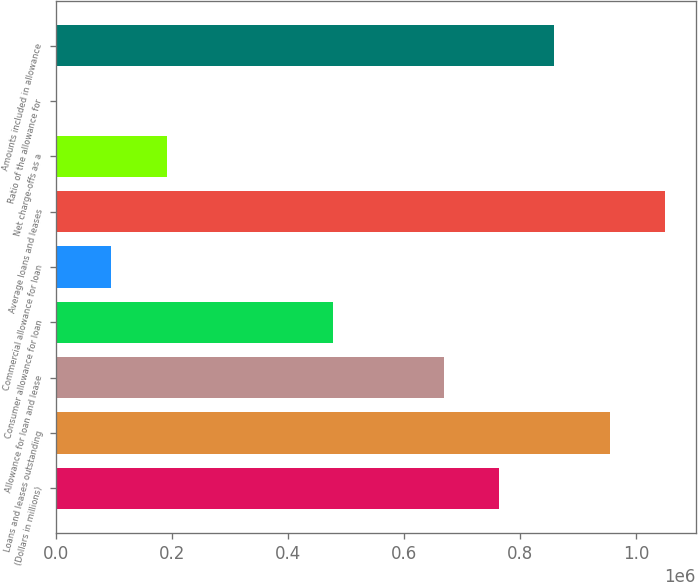Convert chart. <chart><loc_0><loc_0><loc_500><loc_500><bar_chart><fcel>(Dollars in millions)<fcel>Loans and leases outstanding<fcel>Allowance for loan and lease<fcel>Consumer allowance for loan<fcel>Commercial allowance for loan<fcel>Average loans and leases<fcel>Net charge-offs as a<fcel>Ratio of the allowance for<fcel>Amounts included in allowance<nl><fcel>763423<fcel>954278<fcel>667995<fcel>477140<fcel>95428.9<fcel>1.04971e+06<fcel>190857<fcel>1.22<fcel>858850<nl></chart> 